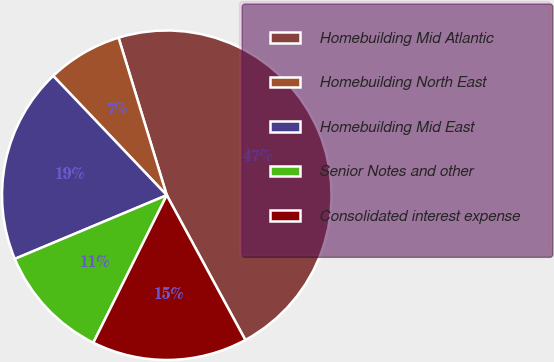Convert chart. <chart><loc_0><loc_0><loc_500><loc_500><pie_chart><fcel>Homebuilding Mid Atlantic<fcel>Homebuilding North East<fcel>Homebuilding Mid East<fcel>Senior Notes and other<fcel>Consolidated interest expense<nl><fcel>46.81%<fcel>7.38%<fcel>19.21%<fcel>11.33%<fcel>15.27%<nl></chart> 